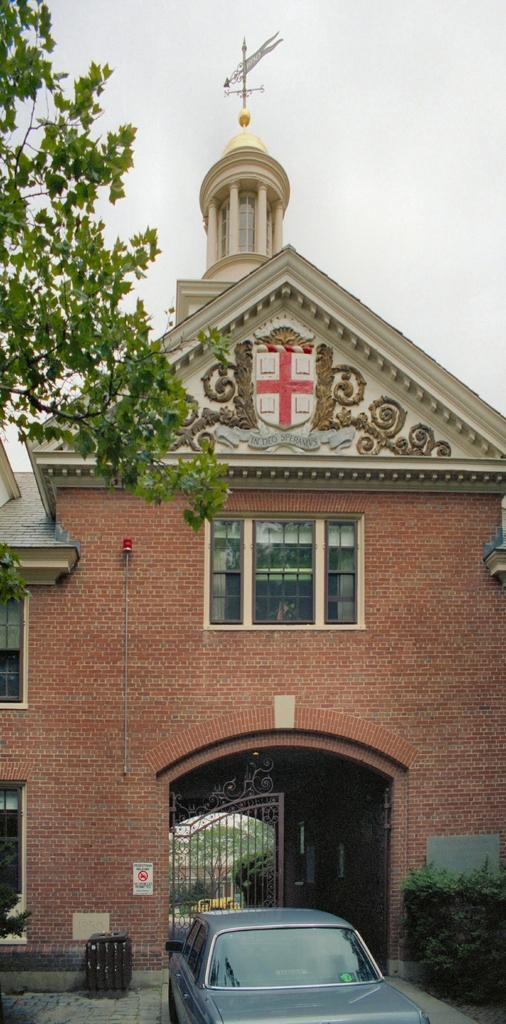What is the main subject of the image? The main subject of the image is a car on the road. What structures can be seen in the image? There are gates in the image. What type of vegetation is present in the image? Plants and trees are visible in the image. What type of signage is present in the image? There is a signboard in the image. What type of building is visible in the image? There is a building with windows in the image. What other objects can be seen in the image? There are some objects in the image. What can be seen in the background of the image? The sky is visible in the background of the image. What type of muscle is being exercised by the plantation in the image? There is no plantation or muscle present in the image. What type of rake is being used by the trees in the image? There is no rake present in the image; the trees are not using any tools. 